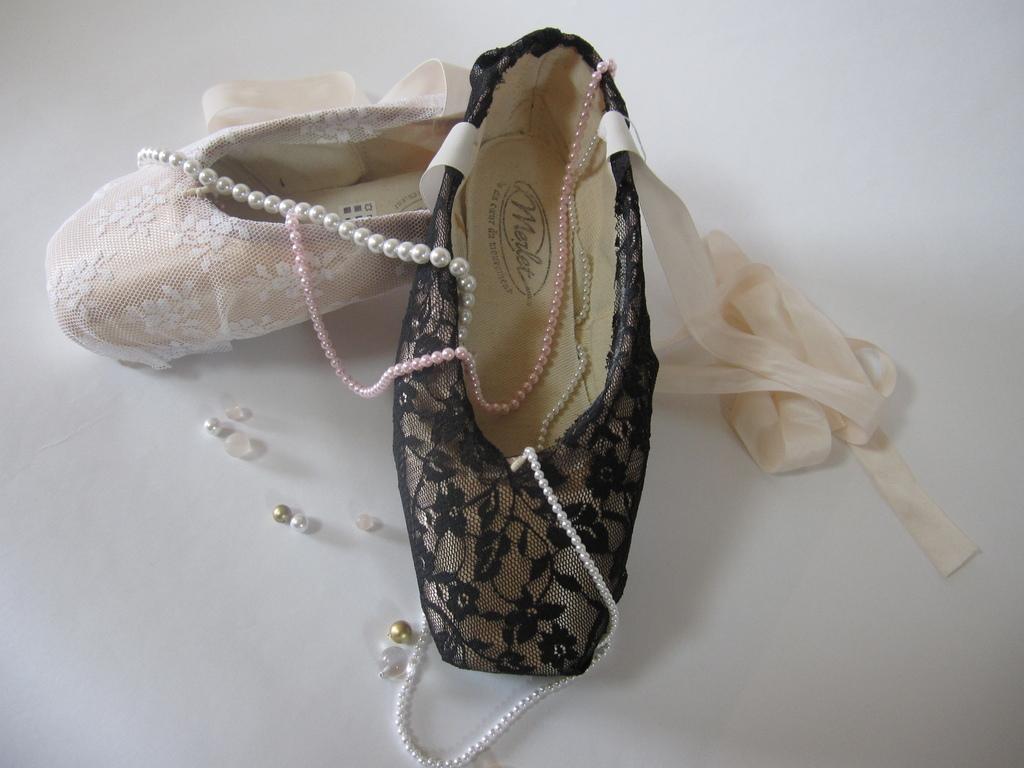Could you give a brief overview of what you see in this image? Here in this picture we can see a pair of shoes present on the floor and we can also see a necklace present. 